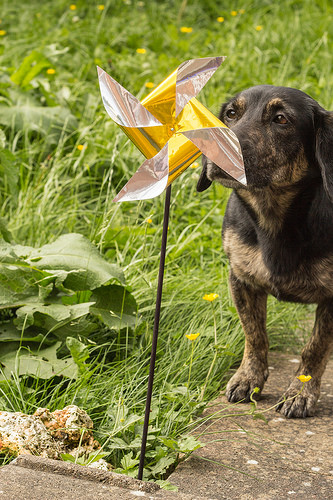<image>
Is the grass under the dog? Yes. The grass is positioned underneath the dog, with the dog above it in the vertical space. 